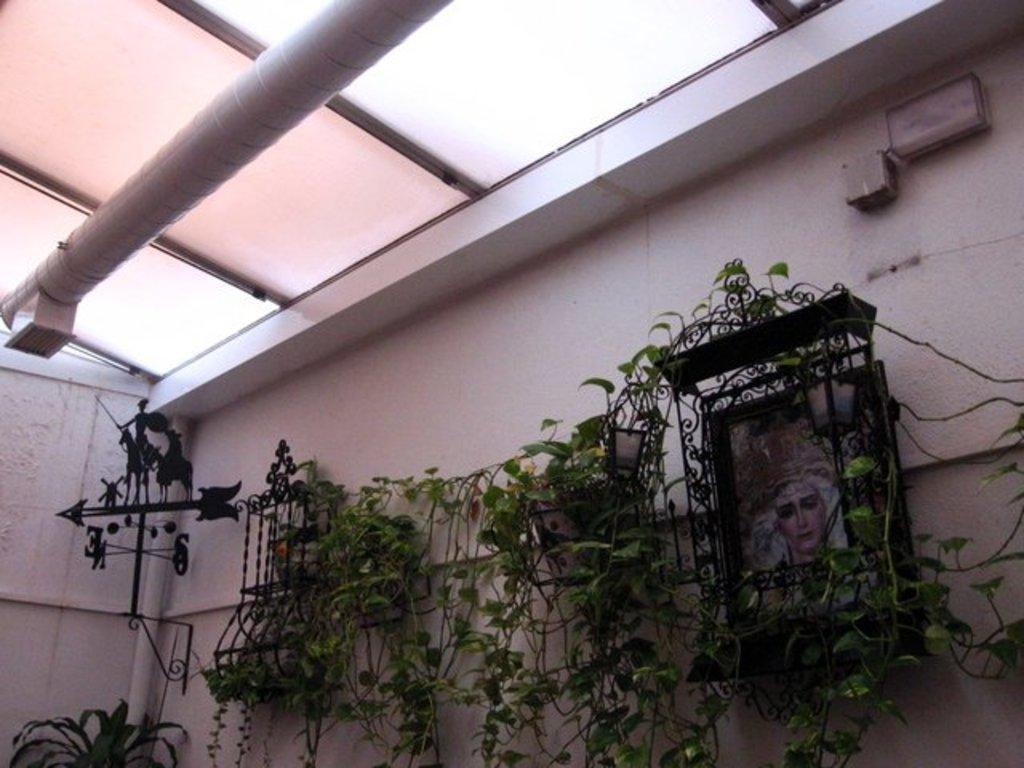What type of living organisms can be seen in the image? Plants can be seen in the image. What is located behind the plants? There is a wall behind the plants. What is hanging on the wall? There are frames on the wall. What is visible at the top of the image? The ceiling is visible at the top of the image. What can be seen near the ceiling? There is a pipe at the top of the image. What type of laborer is working at night in the image? There is no laborer or nighttime setting present in the image. What type of drug is being used by the person in the image? There is no person or drug present in the image. 